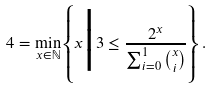<formula> <loc_0><loc_0><loc_500><loc_500>4 = \min _ { x \in \mathbb { N } } \left \{ x \Big | 3 \leq \frac { 2 ^ { x } } { \sum _ { i = 0 } ^ { 1 } \binom { x } { i } } \right \} .</formula> 